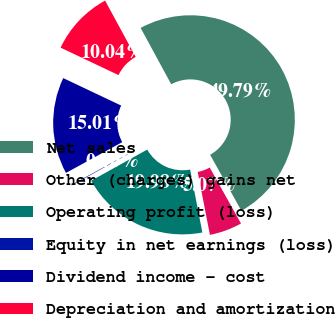Convert chart. <chart><loc_0><loc_0><loc_500><loc_500><pie_chart><fcel>Net sales<fcel>Other (charges) gains net<fcel>Operating profit (loss)<fcel>Equity in net earnings (loss)<fcel>Dividend income - cost<fcel>Depreciation and amortization<nl><fcel>49.79%<fcel>5.07%<fcel>19.98%<fcel>0.1%<fcel>15.01%<fcel>10.04%<nl></chart> 